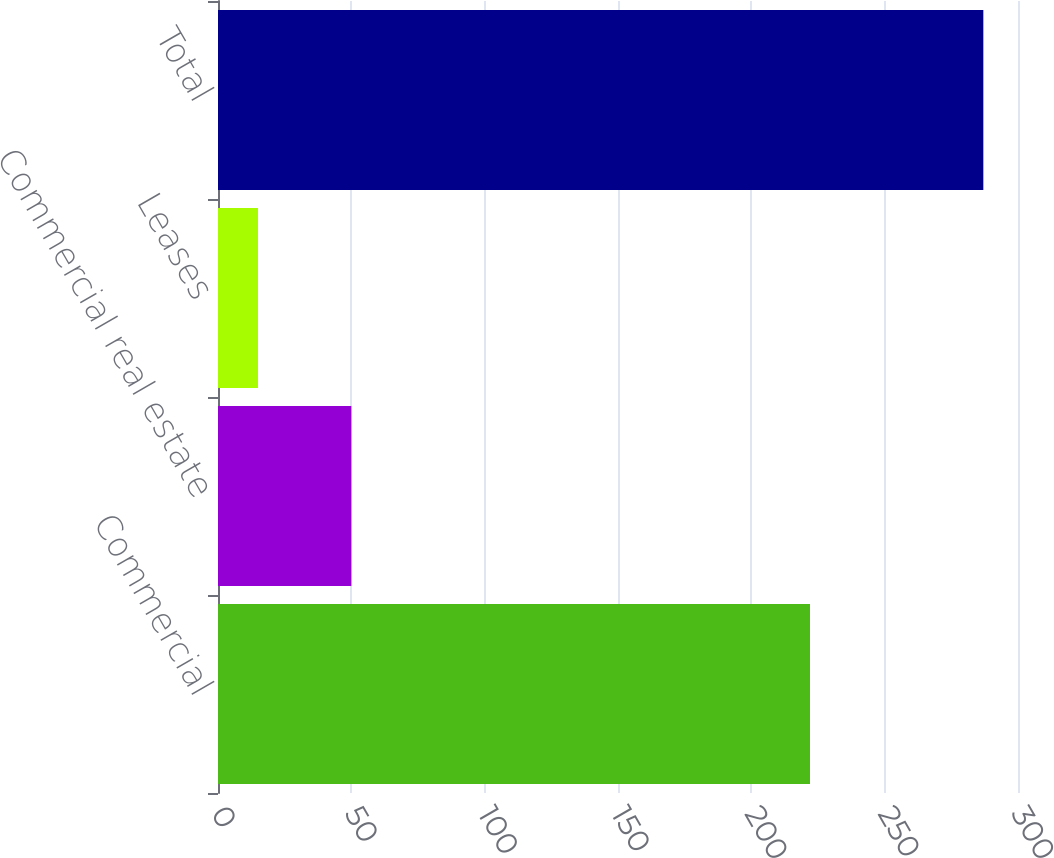<chart> <loc_0><loc_0><loc_500><loc_500><bar_chart><fcel>Commercial<fcel>Commercial real estate<fcel>Leases<fcel>Total<nl><fcel>222<fcel>50<fcel>15<fcel>287<nl></chart> 